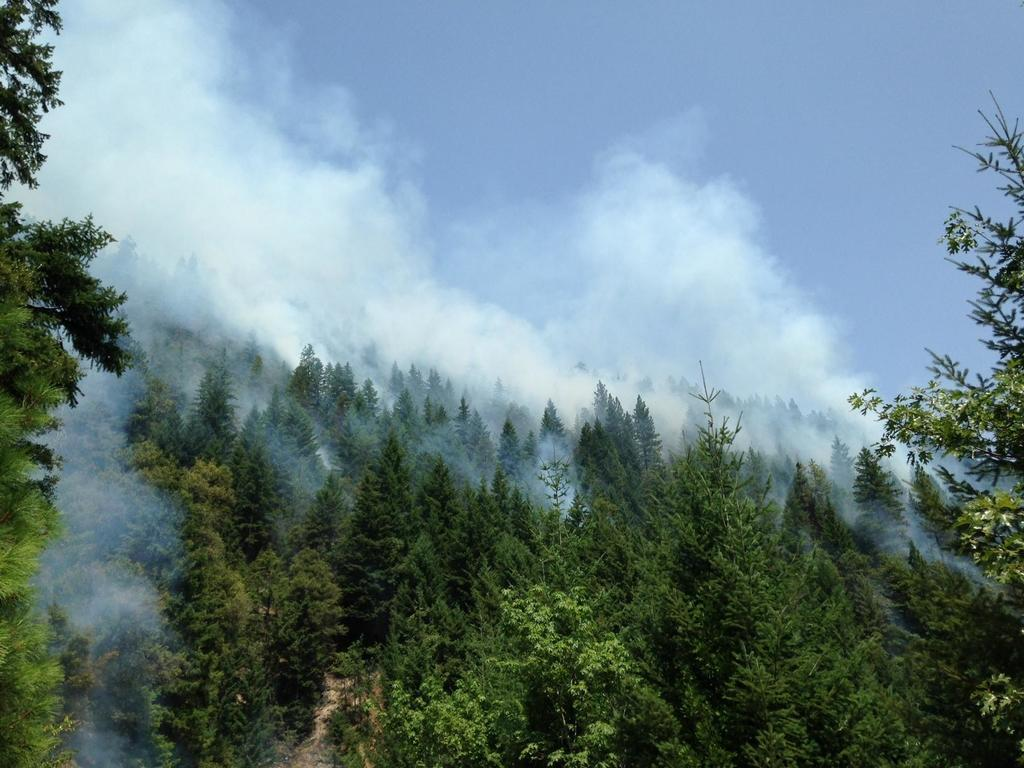What is the dominant feature in the image? There are many trees in the image. What else can be seen in the image besides trees? There is smoke visible in the image. How would you describe the color of the sky in the image? The sky is pale blue in the image. How many men are holding fowl in the image? There are no men or fowl present in the image; it features trees and smoke. What type of notebook is visible in the image? There is no notebook present in the image. 